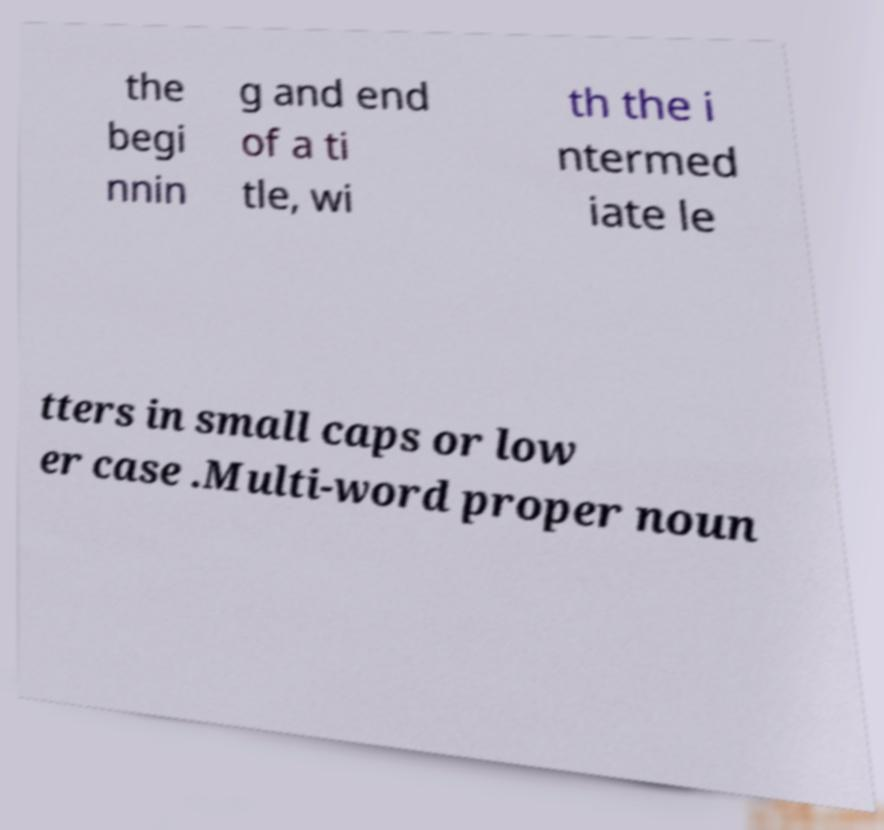Can you read and provide the text displayed in the image?This photo seems to have some interesting text. Can you extract and type it out for me? the begi nnin g and end of a ti tle, wi th the i ntermed iate le tters in small caps or low er case .Multi-word proper noun 